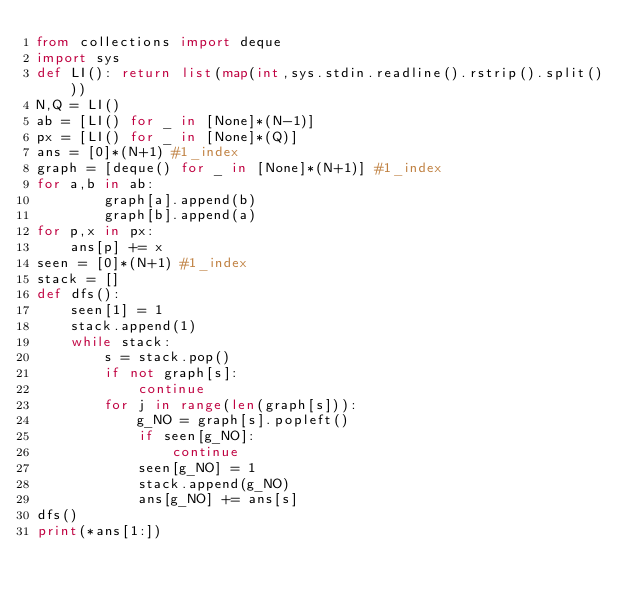Convert code to text. <code><loc_0><loc_0><loc_500><loc_500><_Python_>from collections import deque
import sys
def LI(): return list(map(int,sys.stdin.readline().rstrip().split()))
N,Q = LI()
ab = [LI() for _ in [None]*(N-1)]
px = [LI() for _ in [None]*(Q)]
ans = [0]*(N+1) #1_index
graph = [deque() for _ in [None]*(N+1)] #1_index
for a,b in ab:
        graph[a].append(b)
        graph[b].append(a)
for p,x in px:
    ans[p] += x
seen = [0]*(N+1) #1_index
stack = []
def dfs():
    seen[1] = 1
    stack.append(1)
    while stack:
        s = stack.pop()
        if not graph[s]:
            continue
        for j in range(len(graph[s])):
            g_NO = graph[s].popleft()
            if seen[g_NO]:
                continue
            seen[g_NO] = 1
            stack.append(g_NO)
            ans[g_NO] += ans[s]
dfs()
print(*ans[1:])
</code> 